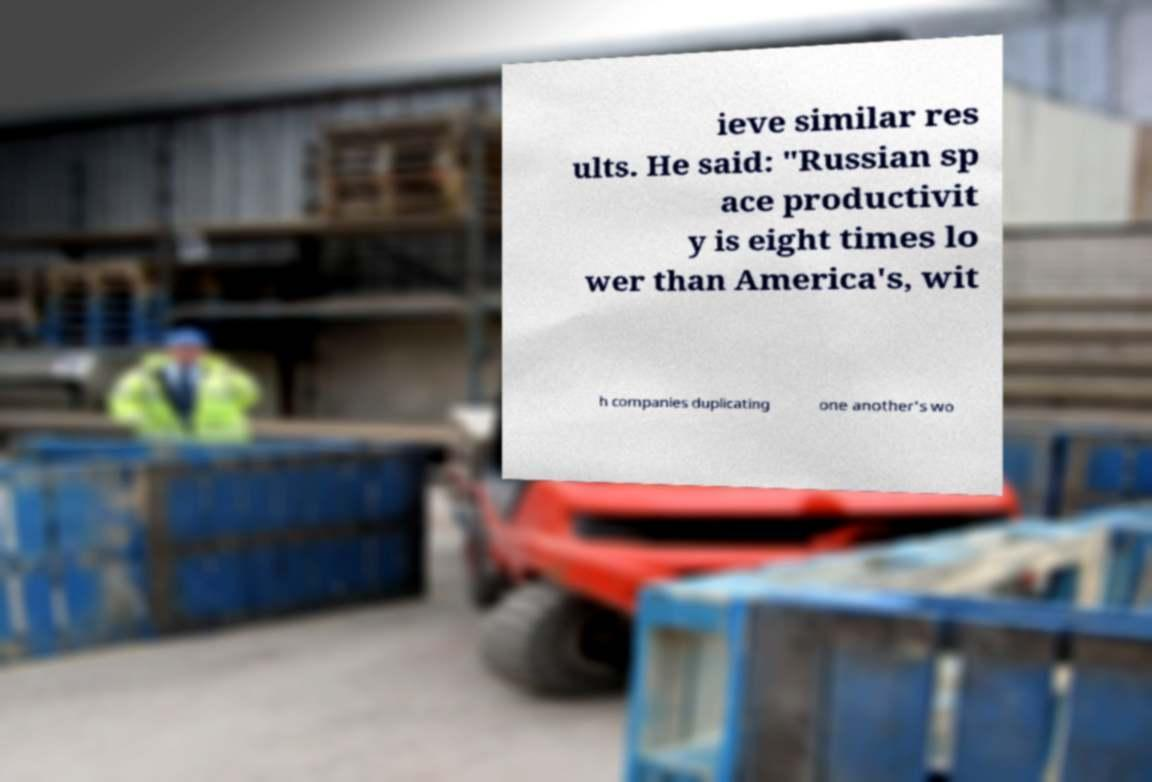Please read and relay the text visible in this image. What does it say? ieve similar res ults. He said: "Russian sp ace productivit y is eight times lo wer than America's, wit h companies duplicating one another's wo 